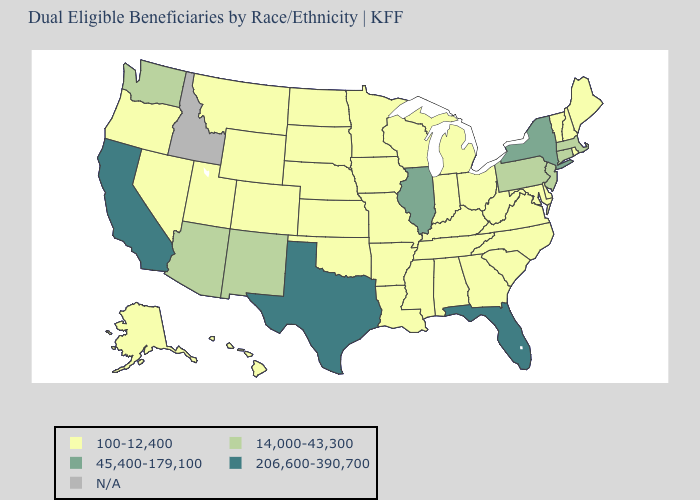Name the states that have a value in the range 206,600-390,700?
Concise answer only. California, Florida, Texas. What is the value of New Jersey?
Answer briefly. 14,000-43,300. What is the value of Alaska?
Concise answer only. 100-12,400. Name the states that have a value in the range 45,400-179,100?
Quick response, please. Illinois, New York. Name the states that have a value in the range 45,400-179,100?
Concise answer only. Illinois, New York. Name the states that have a value in the range N/A?
Answer briefly. Idaho. Name the states that have a value in the range 14,000-43,300?
Write a very short answer. Arizona, Connecticut, Massachusetts, New Jersey, New Mexico, Pennsylvania, Washington. Does Texas have the lowest value in the USA?
Keep it brief. No. Name the states that have a value in the range 45,400-179,100?
Be succinct. Illinois, New York. Name the states that have a value in the range 100-12,400?
Answer briefly. Alabama, Alaska, Arkansas, Colorado, Delaware, Georgia, Hawaii, Indiana, Iowa, Kansas, Kentucky, Louisiana, Maine, Maryland, Michigan, Minnesota, Mississippi, Missouri, Montana, Nebraska, Nevada, New Hampshire, North Carolina, North Dakota, Ohio, Oklahoma, Oregon, Rhode Island, South Carolina, South Dakota, Tennessee, Utah, Vermont, Virginia, West Virginia, Wisconsin, Wyoming. Which states have the highest value in the USA?
Keep it brief. California, Florida, Texas. Name the states that have a value in the range N/A?
Be succinct. Idaho. Does Illinois have the highest value in the MidWest?
Give a very brief answer. Yes. Name the states that have a value in the range N/A?
Be succinct. Idaho. Name the states that have a value in the range 100-12,400?
Concise answer only. Alabama, Alaska, Arkansas, Colorado, Delaware, Georgia, Hawaii, Indiana, Iowa, Kansas, Kentucky, Louisiana, Maine, Maryland, Michigan, Minnesota, Mississippi, Missouri, Montana, Nebraska, Nevada, New Hampshire, North Carolina, North Dakota, Ohio, Oklahoma, Oregon, Rhode Island, South Carolina, South Dakota, Tennessee, Utah, Vermont, Virginia, West Virginia, Wisconsin, Wyoming. 